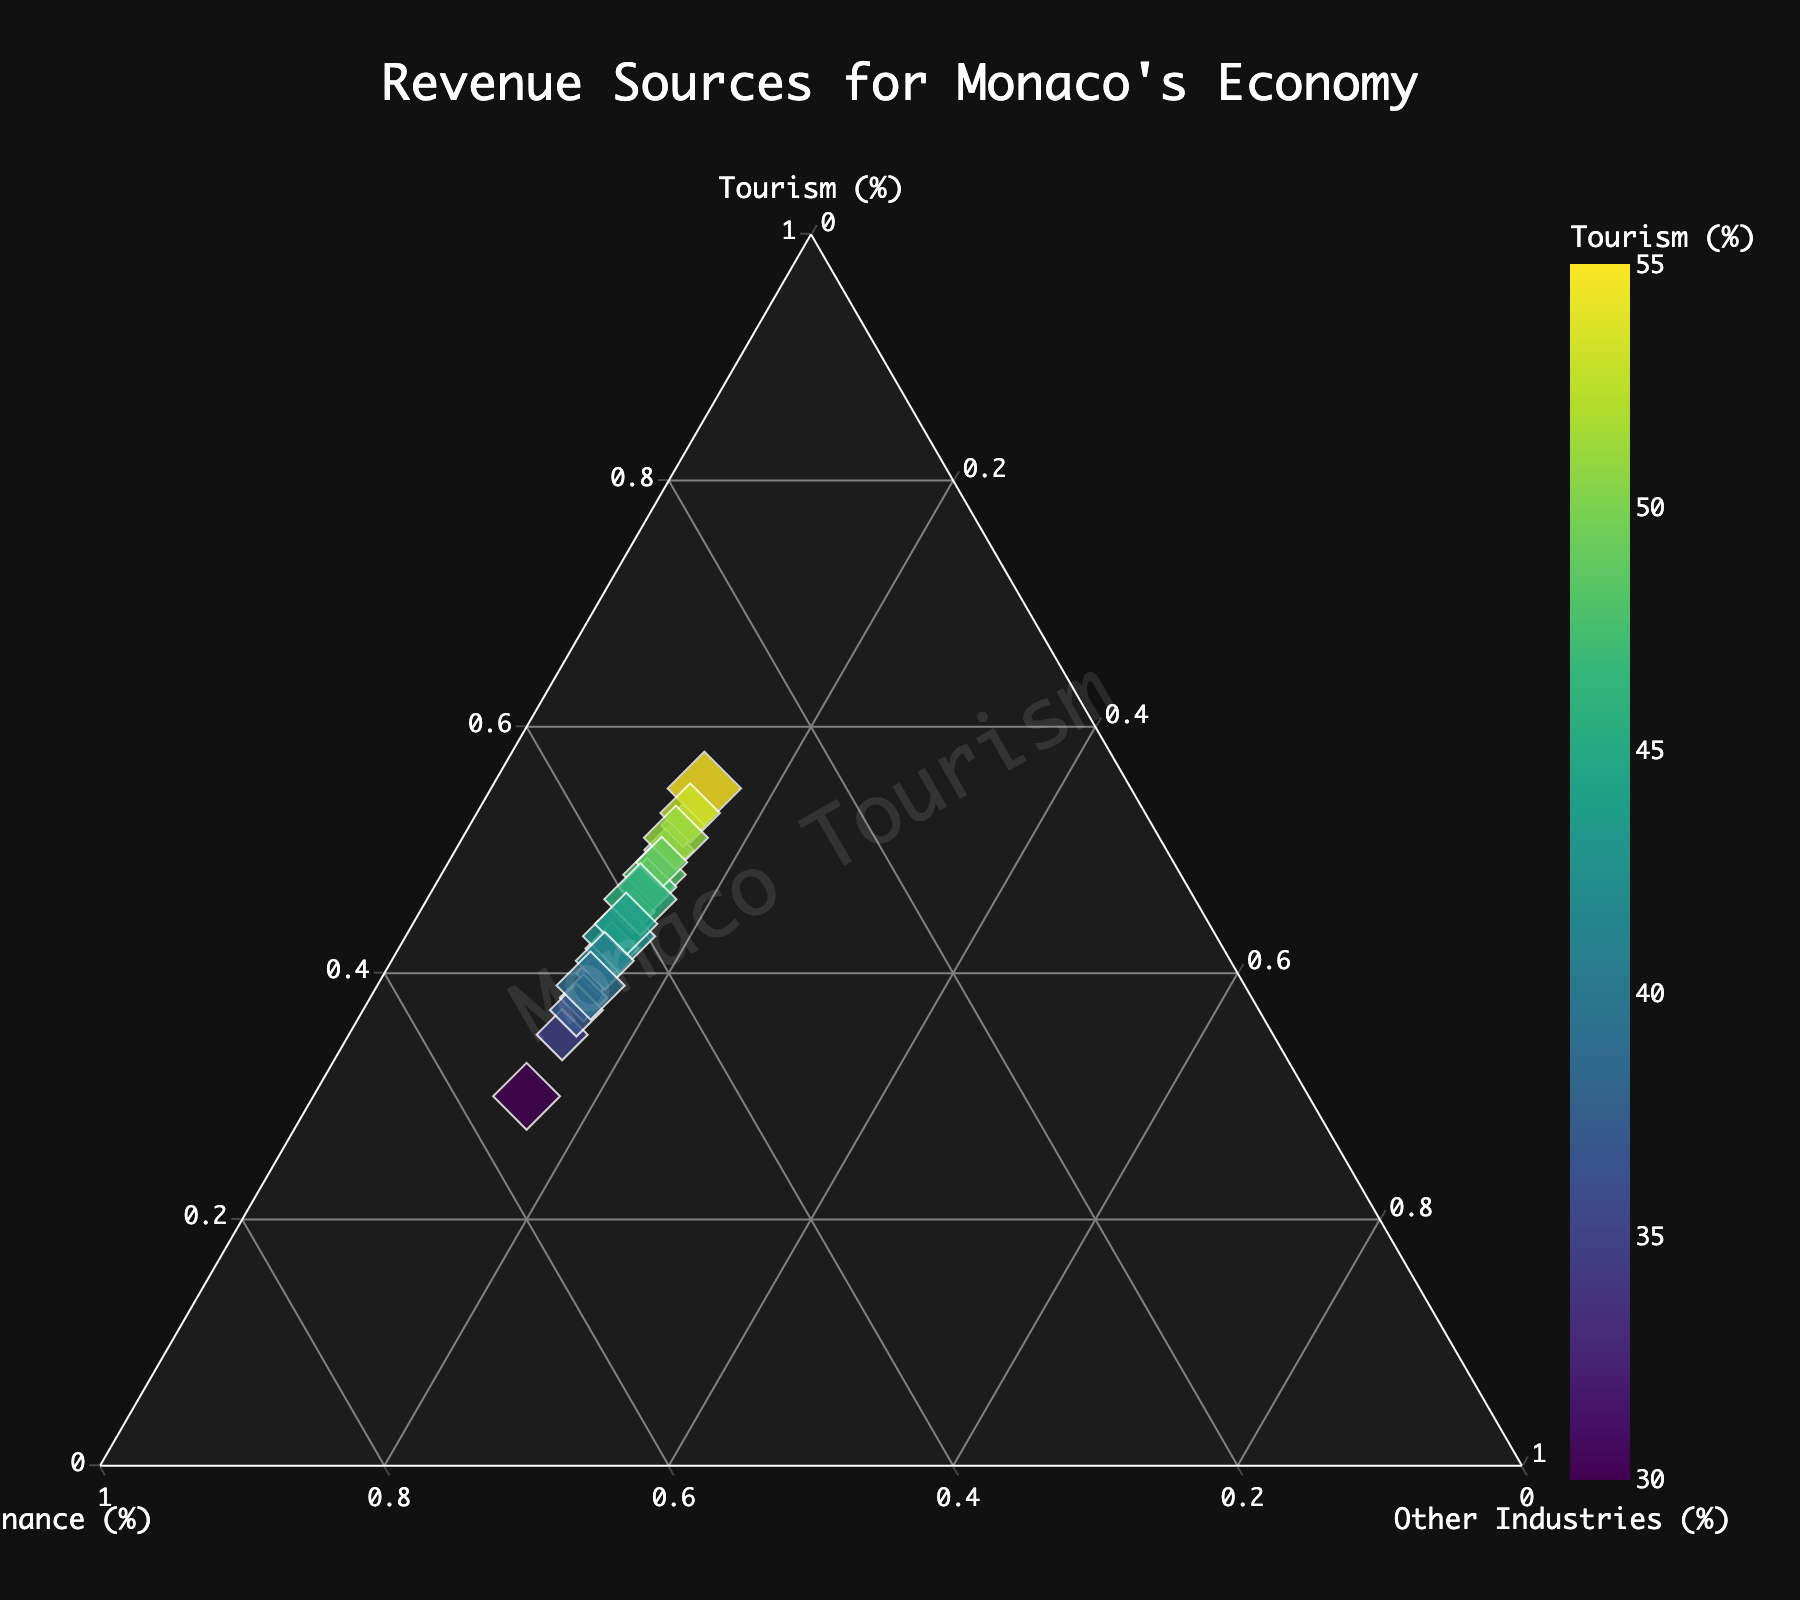What's the title of the figure? The title is usually displayed prominently at the top of the plot. The title of this figure is "Revenue Sources for Monaco's Economy."
Answer: Revenue Sources for Monaco's Economy How many revenue sources are visualized in this figure? Look for the labels on the plot, such as Tourism, Finance, and Other Industries. These represent the revenue sources.
Answer: 3 What's the range of Finance percentages in the data points? Look along the axis labeled "Finance" to see the distribution of values. The values range from 30% to 55%.
Answer: 30% to 55% Which revenue source is colored to represent variations, and what color scheme is used? The plot uses a color gradient to represent variations in one of the variables on the ternary plot. In this case, the plot uses the Viridis color scale to represent variations in Tourism.
Answer: Tourism, Viridis What is the most common percentage value for Other Industries? All data points have the same percentage for Other Industries, which is a straightforward observation from the plot.
Answer: 15% What is the median value of Tourism percentages? List all the Tourism percentages and find the middle value when they are ordered. We have the values: 30, 35, 37, 38, 39, 40, 41, 42, 43, 44, 45, 46, 47, 48, 49, 50, 51, 52, 53, 55; the median of these values is the average of the 10th and 11th values. (44 + 45) / 2 = 44.5
Answer: 44.5% Which data point has the highest Tourism percentage, and what are its other values? Identify the point with the highest percentage on the Tourism axis. This point has 55% in Tourism, 30% in Finance, and 15% in Other Industries.
Answer: Tourism 55%, Finance 30%, Other Industries 15% Is there a visible trend between Tourism and Finance percentages? By observing the distribution and alignment of the data points, you can see that as the percentage of Tourism increases, the percentage of Finance generally decreases, indicating an inverse relationship.
Answer: Inverse relationship Does any data point have equal percentages for Tourism and Finance? Check the plot to see if there is any point exactly on the line where Tourism = Finance. There is no such point in the given data.
Answer: No Which axis shows the constant percentage value across all data points? Look at all three axes—Tourism, Finance, and Other Industries. The Other Industries axis consistently shows 15% across all data points.
Answer: Other Industries 